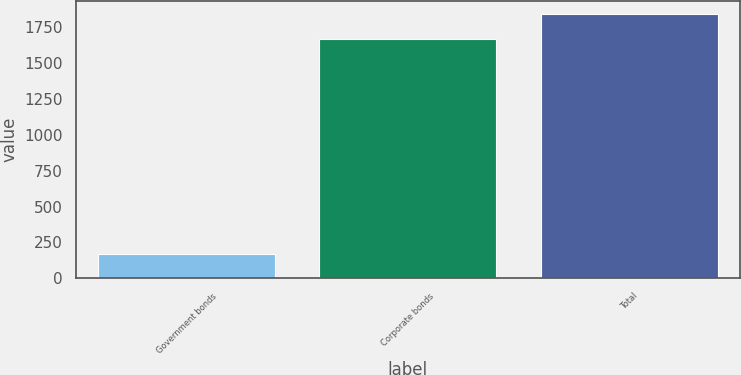Convert chart to OTSL. <chart><loc_0><loc_0><loc_500><loc_500><bar_chart><fcel>Government bonds<fcel>Corporate bonds<fcel>Total<nl><fcel>169<fcel>1671<fcel>1840<nl></chart> 